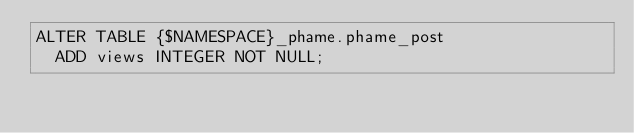Convert code to text. <code><loc_0><loc_0><loc_500><loc_500><_SQL_>ALTER TABLE {$NAMESPACE}_phame.phame_post
  ADD views INTEGER NOT NULL;
</code> 